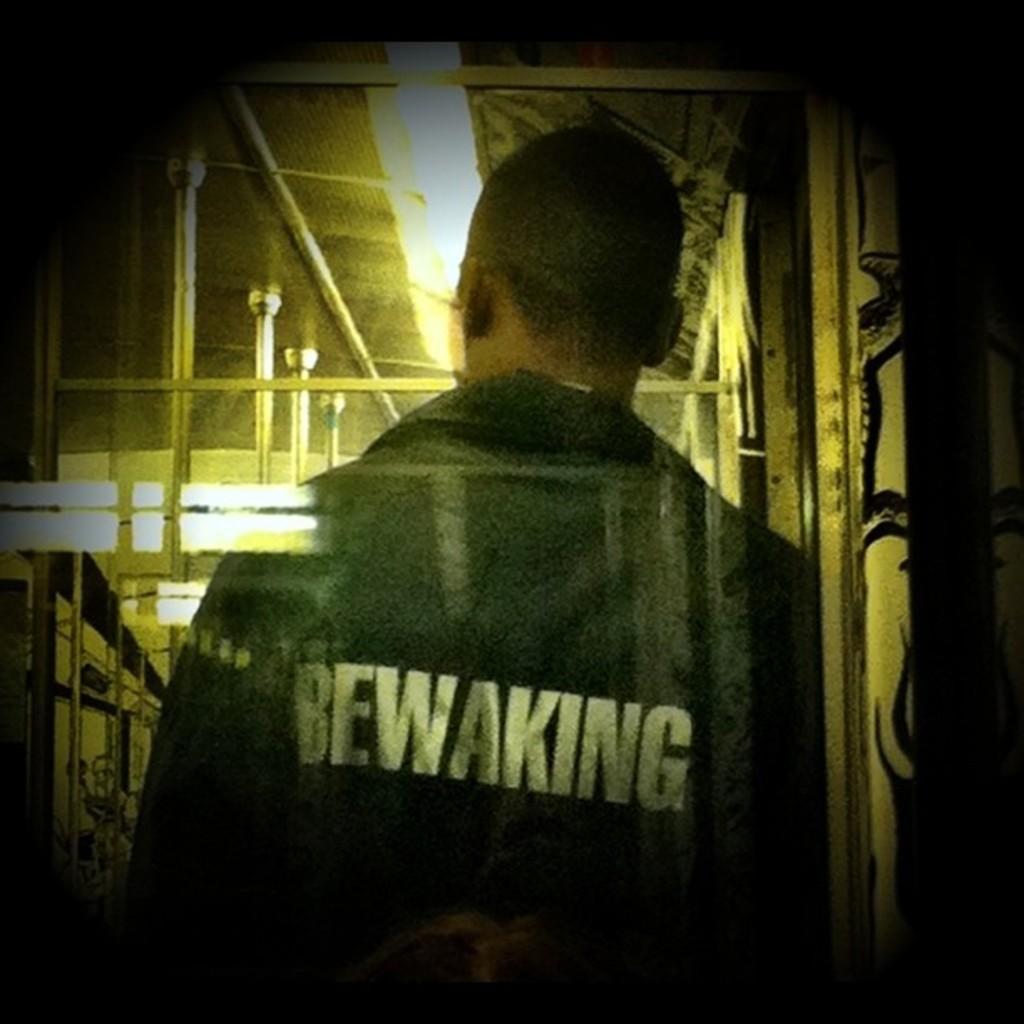Please provide a concise description of this image. In the picture we can see a photograph of a man standing and facing back side and behind his shirt it is written as be waking and in front of him we can see some poles and to the ceiling we can see a light. 